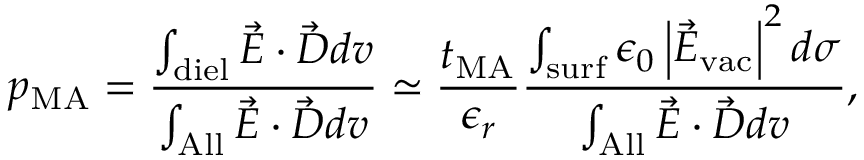<formula> <loc_0><loc_0><loc_500><loc_500>p _ { M A } = \frac { \int _ { d i e l } \vec { E } \cdot \vec { D } d v } { \int _ { A l l } \vec { E } \cdot \vec { D } d v } \simeq \frac { t _ { M A } } { \epsilon _ { r } } \frac { \int _ { s u r f } \epsilon _ { 0 } \left | \vec { E } _ { v a c } \right | ^ { 2 } d \sigma } { \int _ { A l l } \vec { E } \cdot \vec { D } d v } ,</formula> 